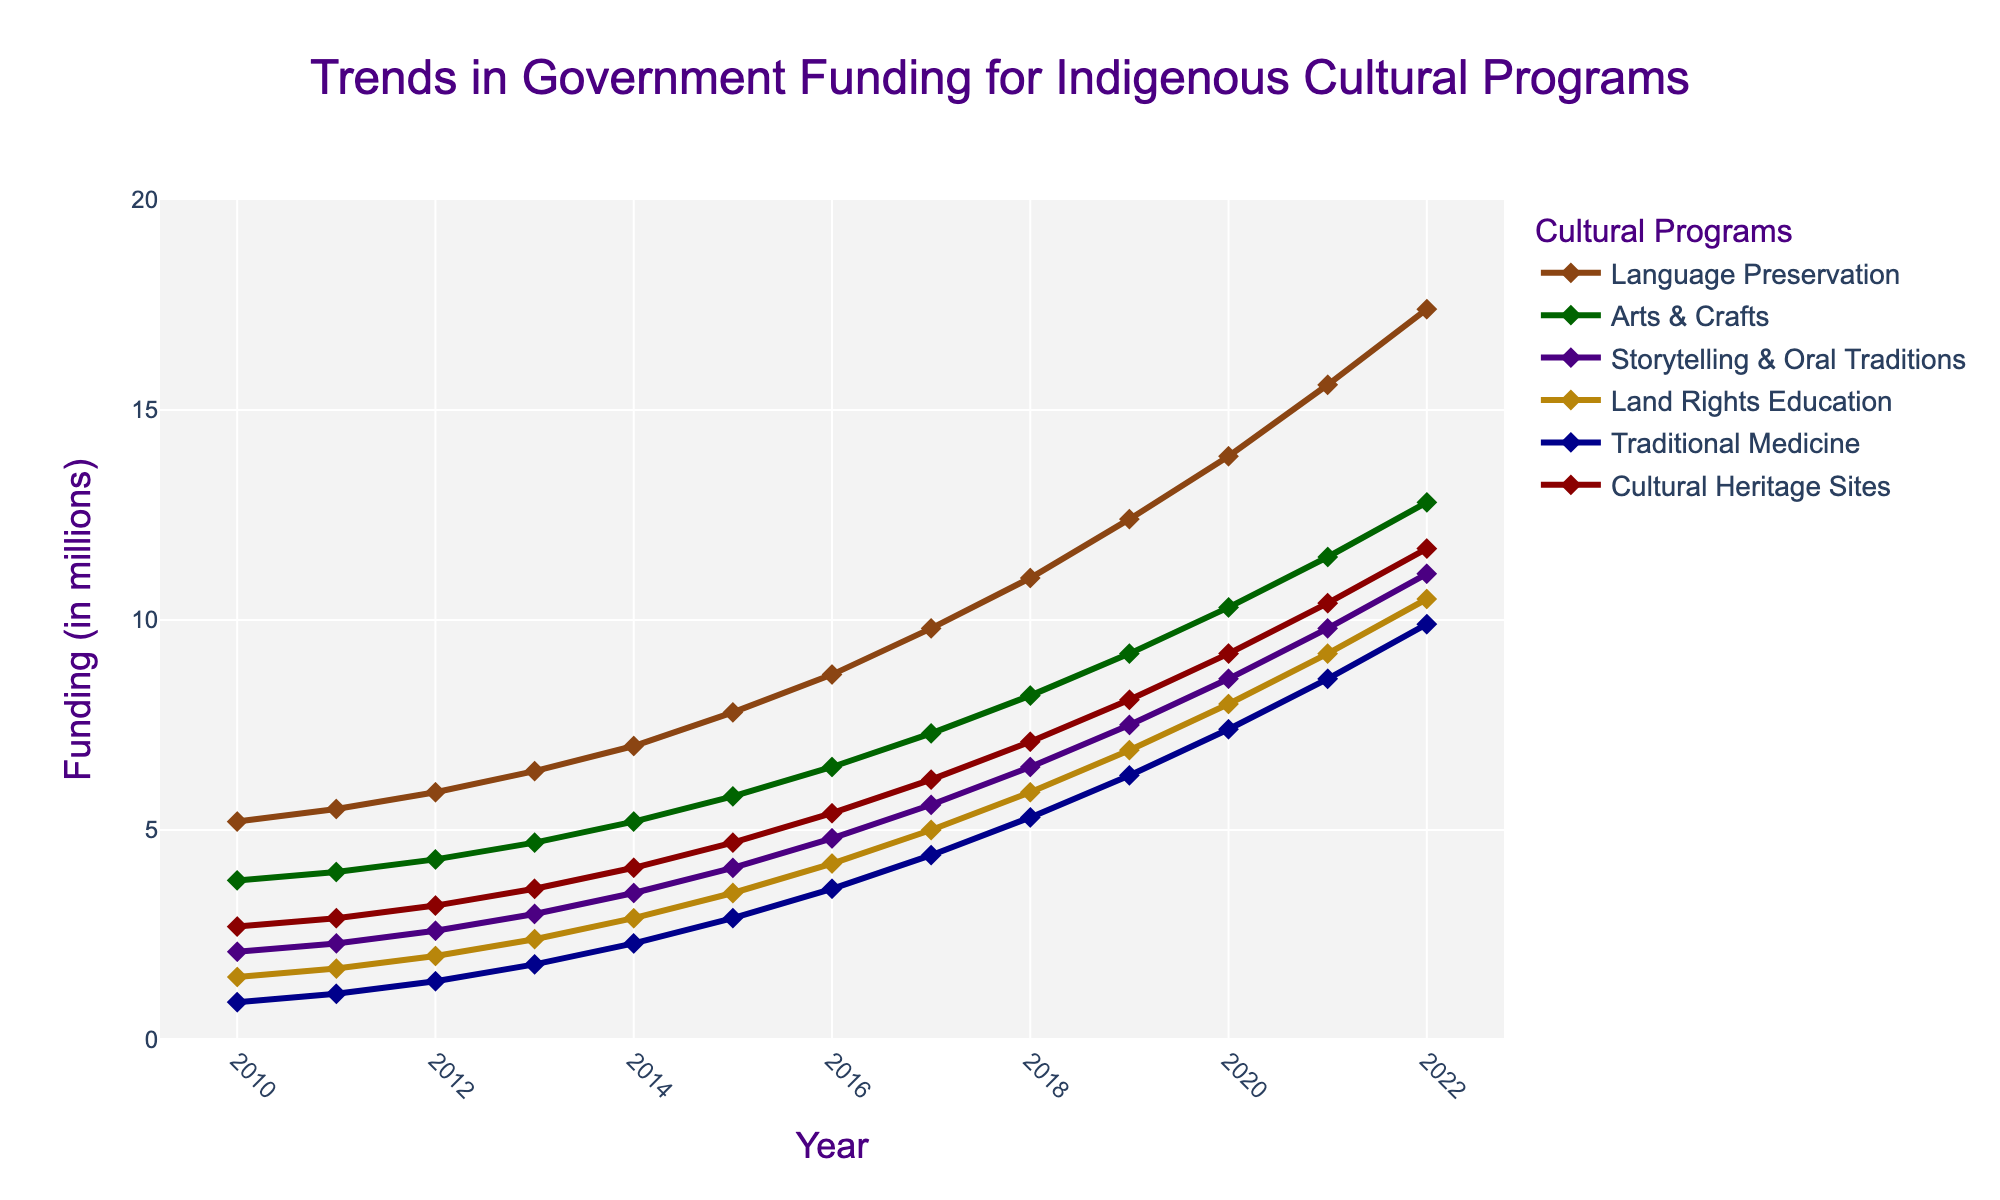Which cultural program had the highest funding increase from 2010 to 2022? First identify the funding amounts for each cultural program in 2010 and 2022, then calculate the increase by subtracting the 2010 value from the 2022 value for each program. Language Preservation increased from 5.2 to 17.4 million, which is an increase of 12.2 million. This is the highest increase among the programs.
Answer: Language Preservation Which cultural program had the smallest funding increase from 2010 to 2022? By calculating the funding increase for each program and comparing them, Traditional Medicine had the smallest increase, from 0.9 million in 2010 to 9.9 million in 2022, which is an increase of 9 million.
Answer: Traditional Medicine In what year did the funding for Land Rights Education surpass 5 million? Check the trend line for Land Rights Education. In 2017, the funding reached 5.0 million and surpassed it in 2018 with 5.9 million.
Answer: 2018 What's the sum of funding for Arts & Crafts and Storytelling & Oral Traditions in 2015? For Arts & Crafts, the funding in 2015 is 5.8 million. For Storytelling & Oral Traditions, the funding is 4.1 million. The sum is calculated as 5.8 + 4.1 = 9.9 million.
Answer: 9.9 million Which year saw the highest total funding across all cultural programs? Sum the funding for each cultural program per year and compare the totals. The year 2022 has the highest total funding.
Answer: 2022 Which cultural program had a higher funding in 2015: Land Rights Education or Traditional Medicine? Look at the values for each program in 2015. Land Rights Education had 3.5 million, and Traditional Medicine had 2.9 million. Therefore, Land Rights Education had higher funding.
Answer: Land Rights Education What is the average annual funding for Cultural Heritage Sites from 2010 to 2015? Sum the annual funding amounts for Cultural Heritage Sites from 2010 to 2015 and divide by the number of years. (2.7 + 2.9 + 3.2 + 3.6 + 4.1 + 4.7) / 6 = 21.2 / 6 = 3.53 million.
Answer: 3.53 million By how much did the funding for Language Preservation change from 2016 to 2020? Identify the funding for Language Preservation in 2016 and 2020. The change is 13.9 million - 8.7 million = 5.2 million.
Answer: 5.2 million Which funding line is represented by the color green? Observe the color-coded traces on the plot. Arts & Crafts is represented by the color green.
Answer: Arts & Crafts 